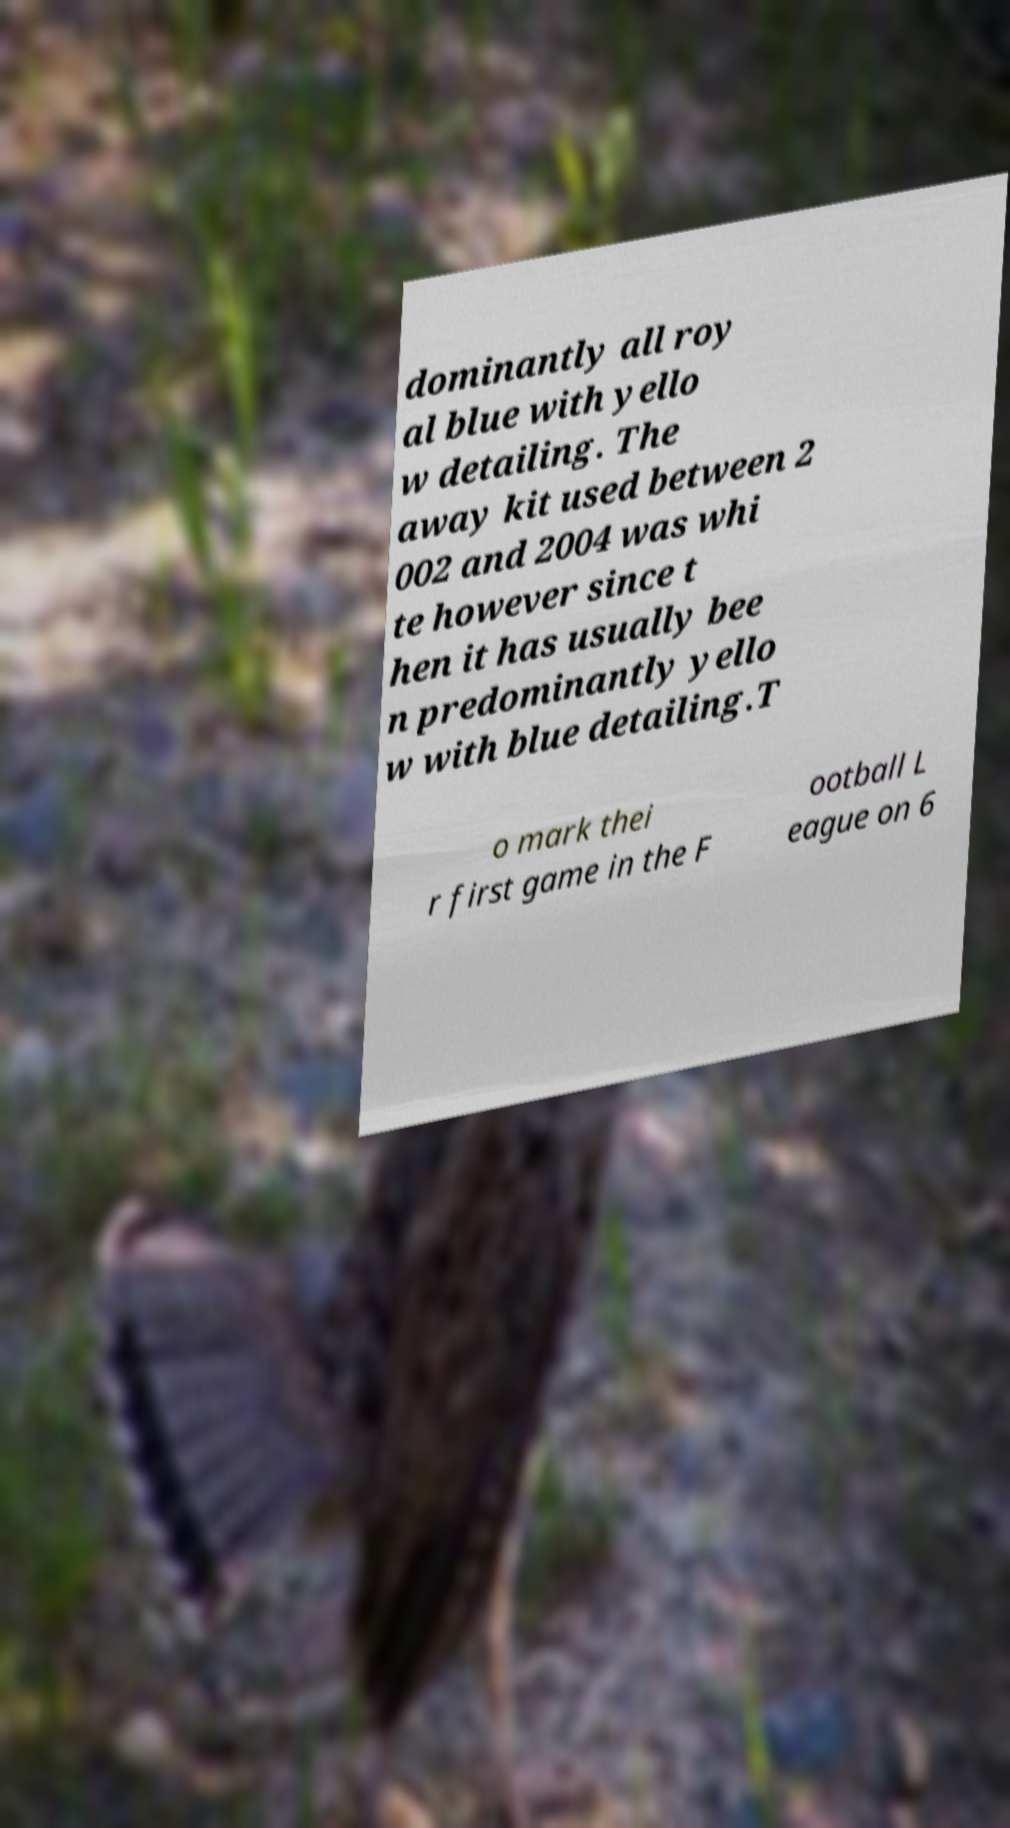What messages or text are displayed in this image? I need them in a readable, typed format. dominantly all roy al blue with yello w detailing. The away kit used between 2 002 and 2004 was whi te however since t hen it has usually bee n predominantly yello w with blue detailing.T o mark thei r first game in the F ootball L eague on 6 